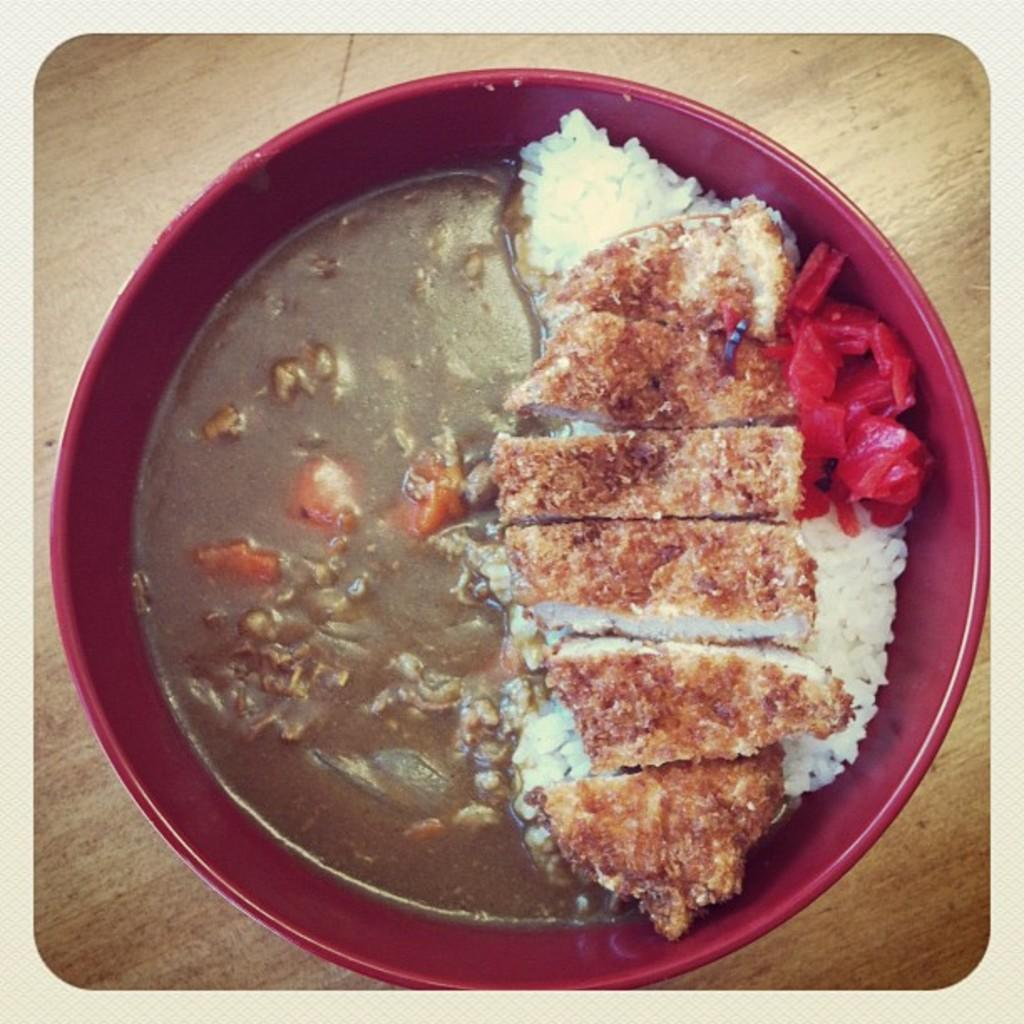What is in the bowl that is visible in the image? There is a bowl with food in the image. Where is the bowl located in the image? The bowl is placed on a wooden platform. What type of ring is the dog wearing in the image? There is no dog or ring present in the image. 